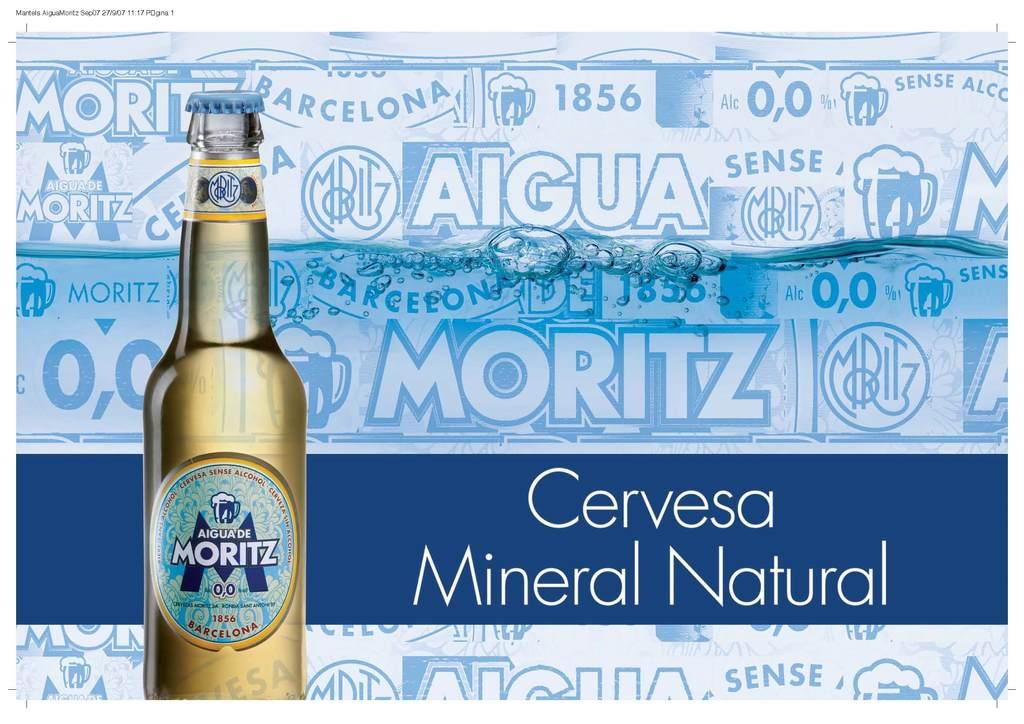<image>
Share a concise interpretation of the image provided. a beer ad the brand is cervesa mineral 